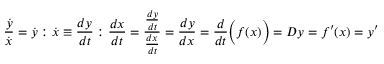<formula> <loc_0><loc_0><loc_500><loc_500>{ \frac { \dot { y } } { \dot { x } } } = { \dot { y } } \colon { \dot { x } } \equiv \frac { d y } { d t } \colon { \frac { d x } { d t } } = { \frac { \frac { d y } { d t } } { \frac { d x } { d t } } } = { \frac { d y } { d x } } = { \frac { d } { d t } } { \left ( } f ( x ) { \right ) } = D y = f ^ { \prime } ( x ) = y ^ { \prime }</formula> 